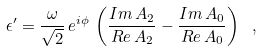Convert formula to latex. <formula><loc_0><loc_0><loc_500><loc_500>\epsilon ^ { \prime } = \frac { \omega } { \sqrt { 2 } } \, e ^ { i \phi } \, \left ( \frac { I m \, A _ { 2 } } { R e \, A _ { 2 } } - \frac { I m \, A _ { 0 } } { R e \, A _ { 0 } } \right ) \ ,</formula> 